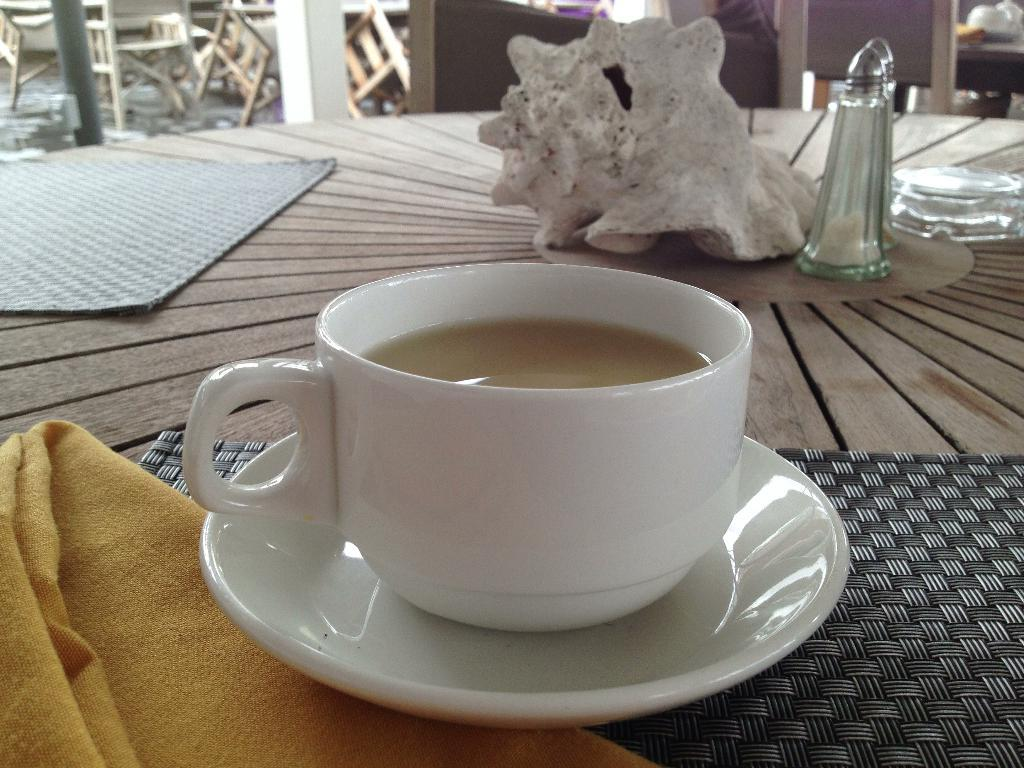What is in the cup that is visible in the image? There is a drink in the cup that is visible in the image. What accompanies the cup in the image? There is a saucer in the image. What can be seen in the background of the image? There is a seashell and a table in the background of the image. What type of furniture is present in the background of the image? There are chairs in the background of the image. What type of apparel is being worn by the library in the image? There is no library present in the image, and therefore no apparel can be associated with it. 